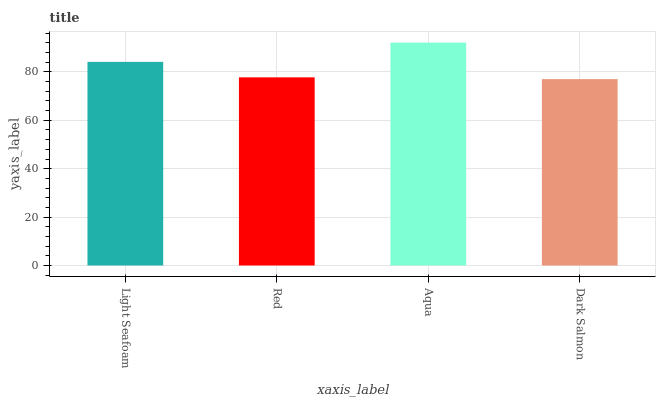Is Dark Salmon the minimum?
Answer yes or no. Yes. Is Aqua the maximum?
Answer yes or no. Yes. Is Red the minimum?
Answer yes or no. No. Is Red the maximum?
Answer yes or no. No. Is Light Seafoam greater than Red?
Answer yes or no. Yes. Is Red less than Light Seafoam?
Answer yes or no. Yes. Is Red greater than Light Seafoam?
Answer yes or no. No. Is Light Seafoam less than Red?
Answer yes or no. No. Is Light Seafoam the high median?
Answer yes or no. Yes. Is Red the low median?
Answer yes or no. Yes. Is Aqua the high median?
Answer yes or no. No. Is Aqua the low median?
Answer yes or no. No. 